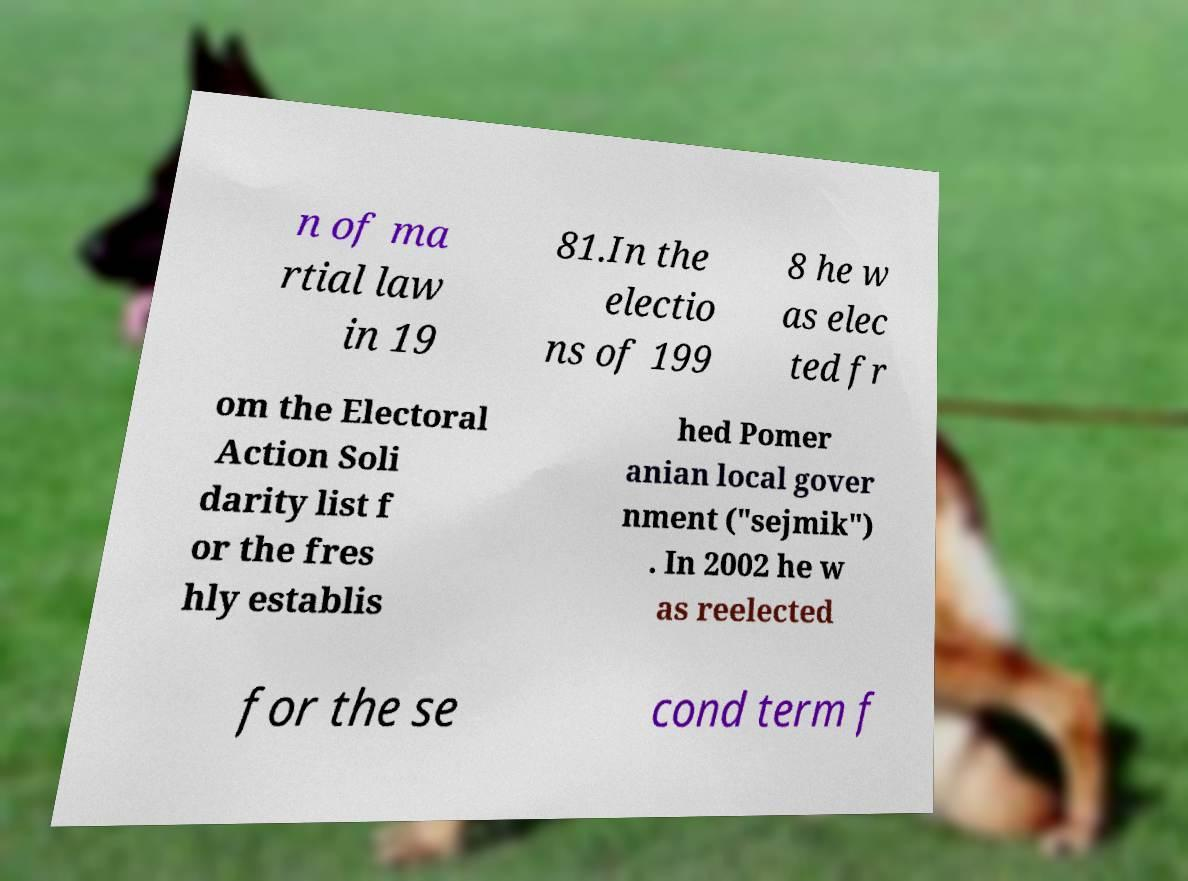Please read and relay the text visible in this image. What does it say? n of ma rtial law in 19 81.In the electio ns of 199 8 he w as elec ted fr om the Electoral Action Soli darity list f or the fres hly establis hed Pomer anian local gover nment ("sejmik") . In 2002 he w as reelected for the se cond term f 